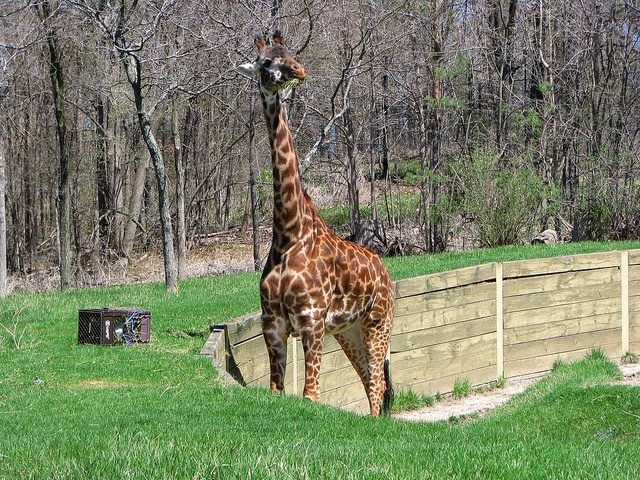Describe the objects in this image and their specific colors. I can see a giraffe in gray, black, and maroon tones in this image. 